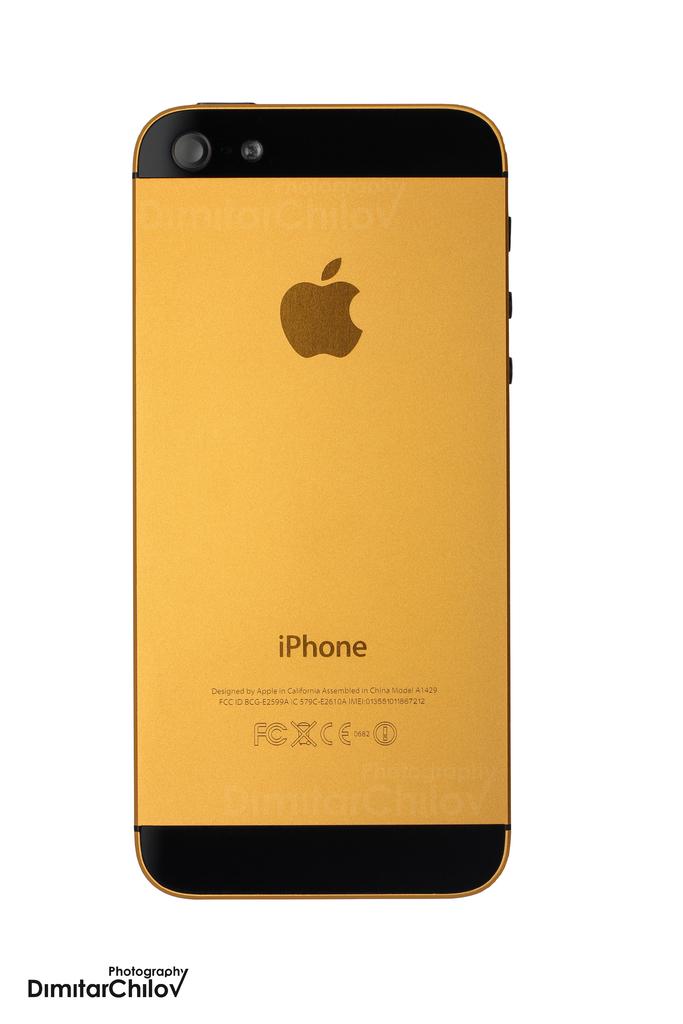What kind of phone is this?
Your answer should be very brief. Iphone. 